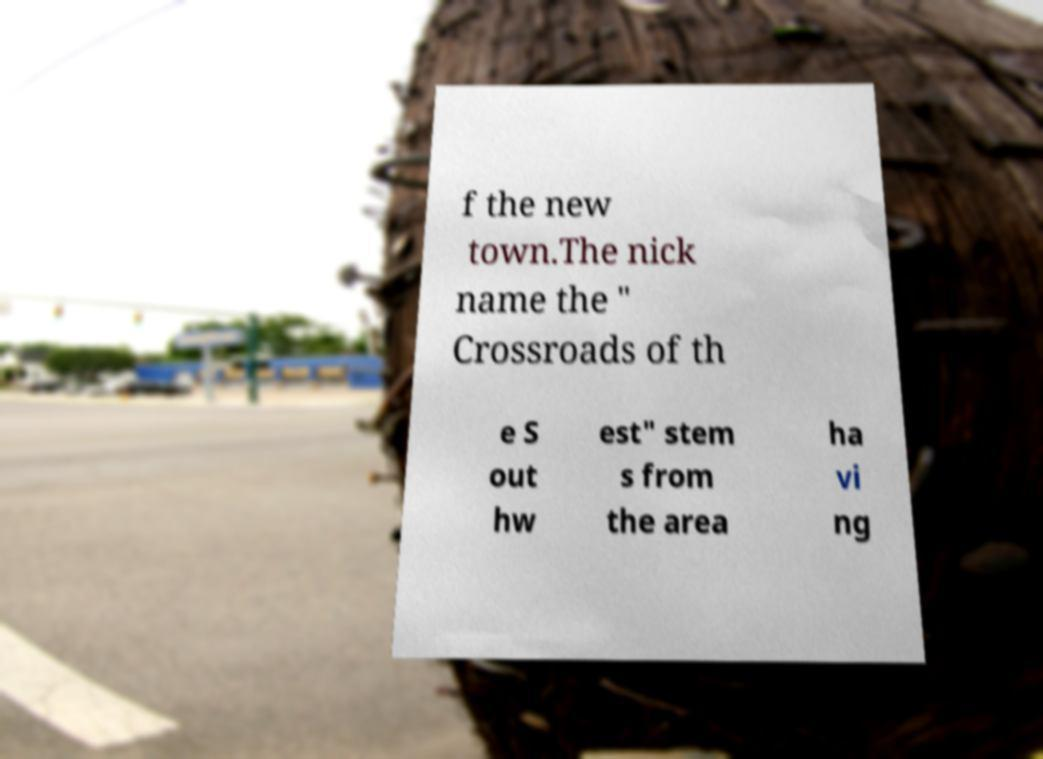There's text embedded in this image that I need extracted. Can you transcribe it verbatim? f the new town.The nick name the " Crossroads of th e S out hw est" stem s from the area ha vi ng 